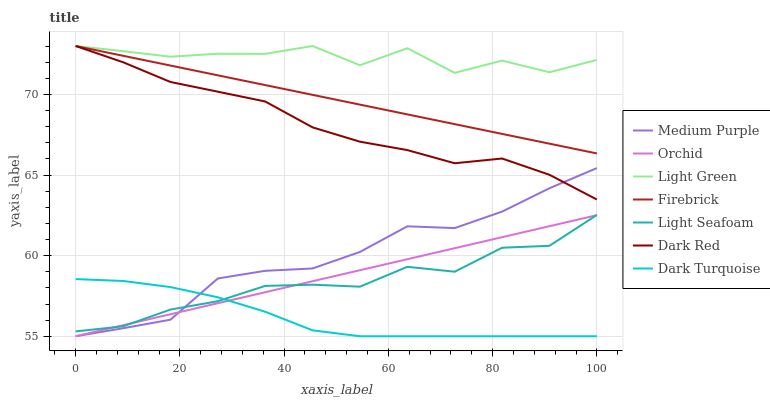Does Dark Turquoise have the minimum area under the curve?
Answer yes or no. Yes. Does Light Green have the maximum area under the curve?
Answer yes or no. Yes. Does Firebrick have the minimum area under the curve?
Answer yes or no. No. Does Firebrick have the maximum area under the curve?
Answer yes or no. No. Is Orchid the smoothest?
Answer yes or no. Yes. Is Light Green the roughest?
Answer yes or no. Yes. Is Firebrick the smoothest?
Answer yes or no. No. Is Firebrick the roughest?
Answer yes or no. No. Does Medium Purple have the lowest value?
Answer yes or no. Yes. Does Firebrick have the lowest value?
Answer yes or no. No. Does Light Green have the highest value?
Answer yes or no. Yes. Does Medium Purple have the highest value?
Answer yes or no. No. Is Medium Purple less than Firebrick?
Answer yes or no. Yes. Is Firebrick greater than Medium Purple?
Answer yes or no. Yes. Does Dark Red intersect Medium Purple?
Answer yes or no. Yes. Is Dark Red less than Medium Purple?
Answer yes or no. No. Is Dark Red greater than Medium Purple?
Answer yes or no. No. Does Medium Purple intersect Firebrick?
Answer yes or no. No. 